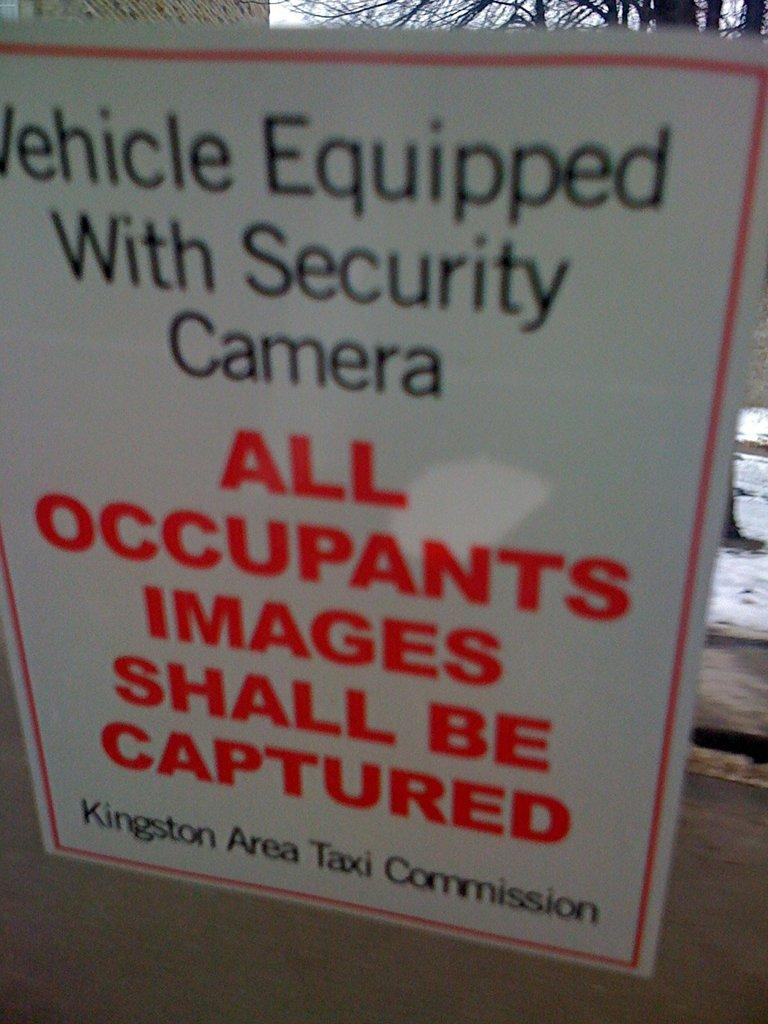<image>
Create a compact narrative representing the image presented. Sign that says vehicle equipped with security camera 